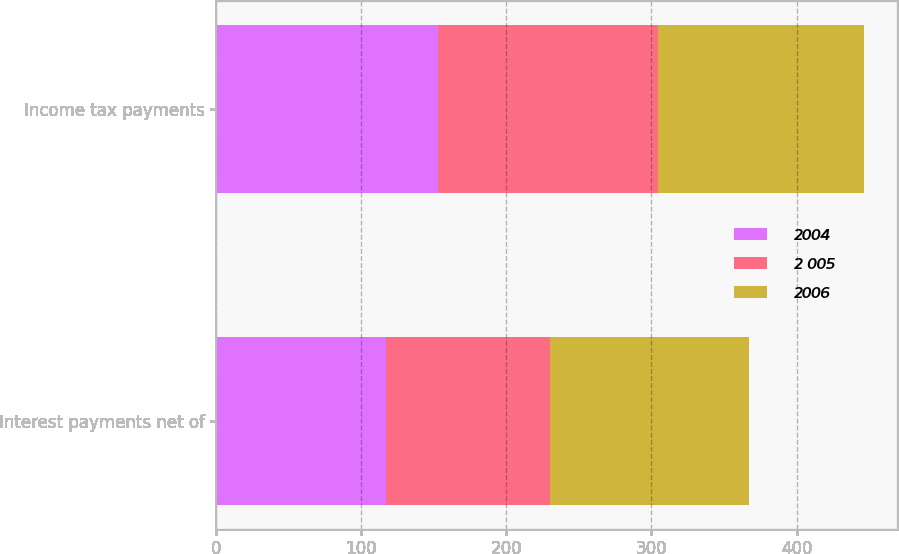<chart> <loc_0><loc_0><loc_500><loc_500><stacked_bar_chart><ecel><fcel>Interest payments net of<fcel>Income tax payments<nl><fcel>2004<fcel>116.7<fcel>152.6<nl><fcel>2 005<fcel>113.6<fcel>152.2<nl><fcel>2006<fcel>136.6<fcel>141.9<nl></chart> 